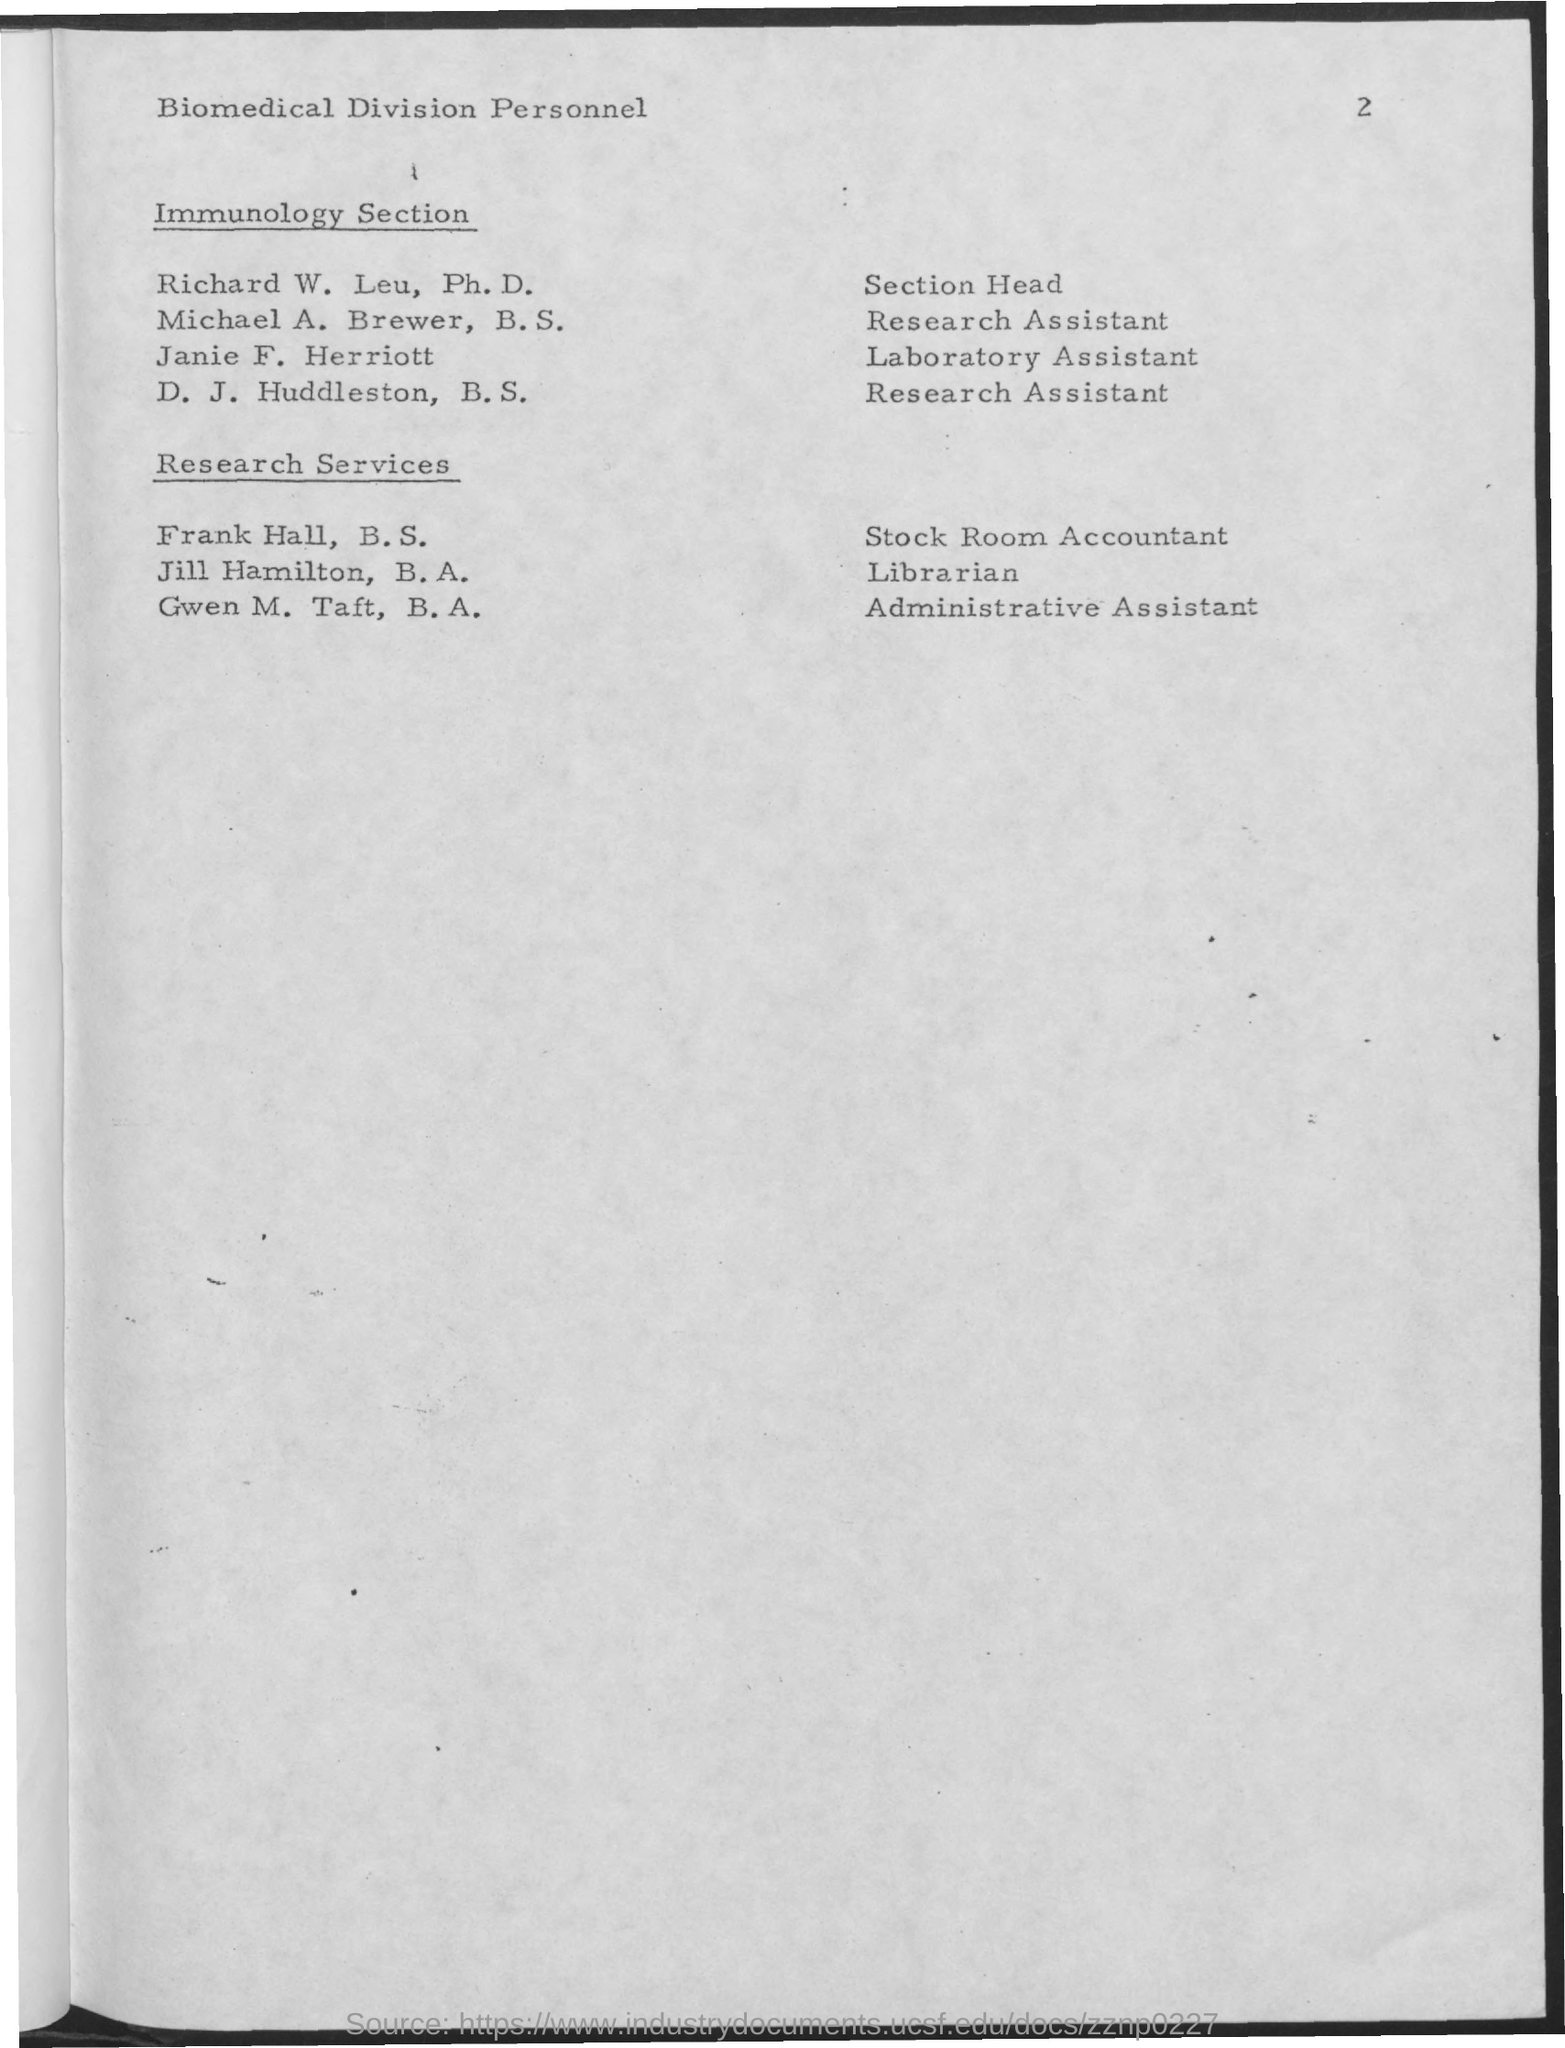Point out several critical features in this image. Frank Hall holds the designation of B.S. and is currently serving as a Stock Room Accountant. The laboratory assistant in the immunology section is named Janie F. Herriott. 